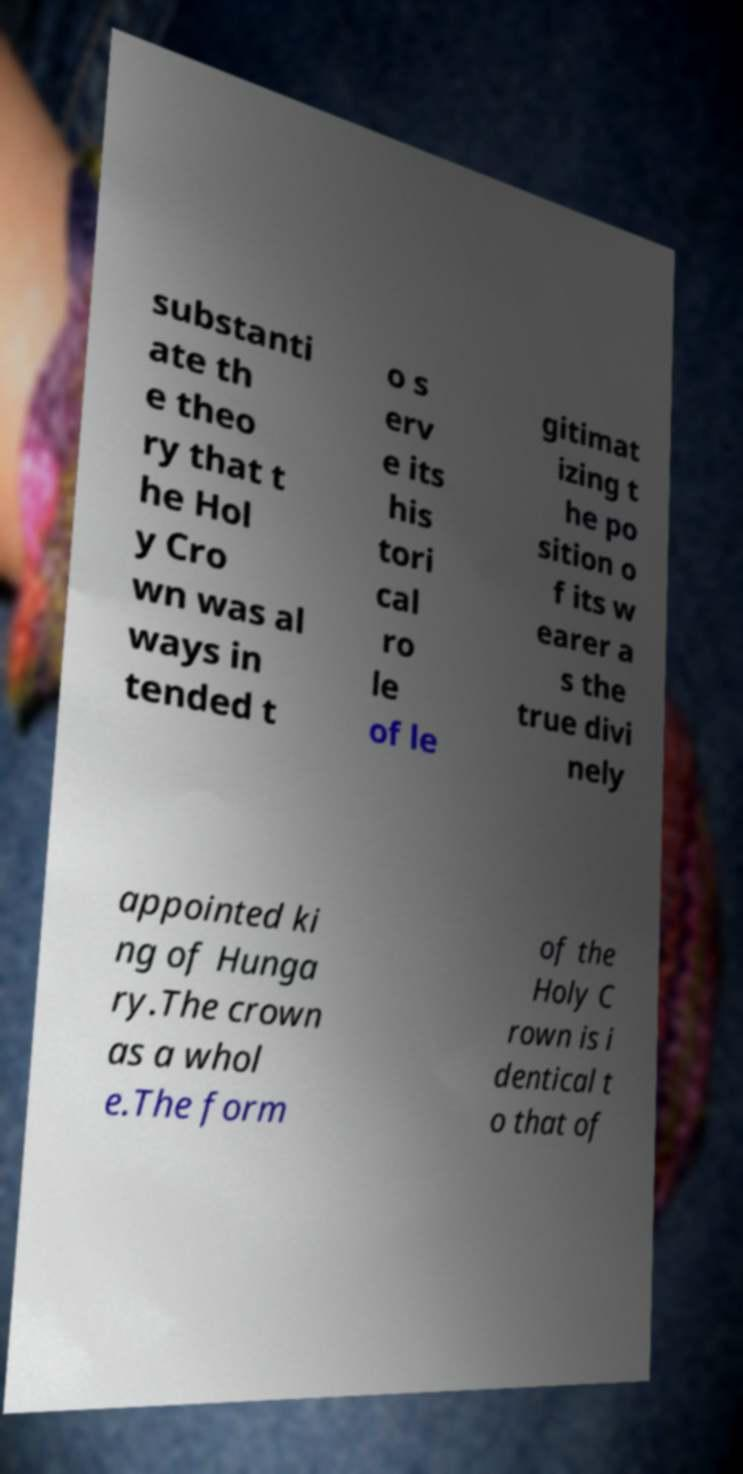Could you extract and type out the text from this image? substanti ate th e theo ry that t he Hol y Cro wn was al ways in tended t o s erv e its his tori cal ro le of le gitimat izing t he po sition o f its w earer a s the true divi nely appointed ki ng of Hunga ry.The crown as a whol e.The form of the Holy C rown is i dentical t o that of 